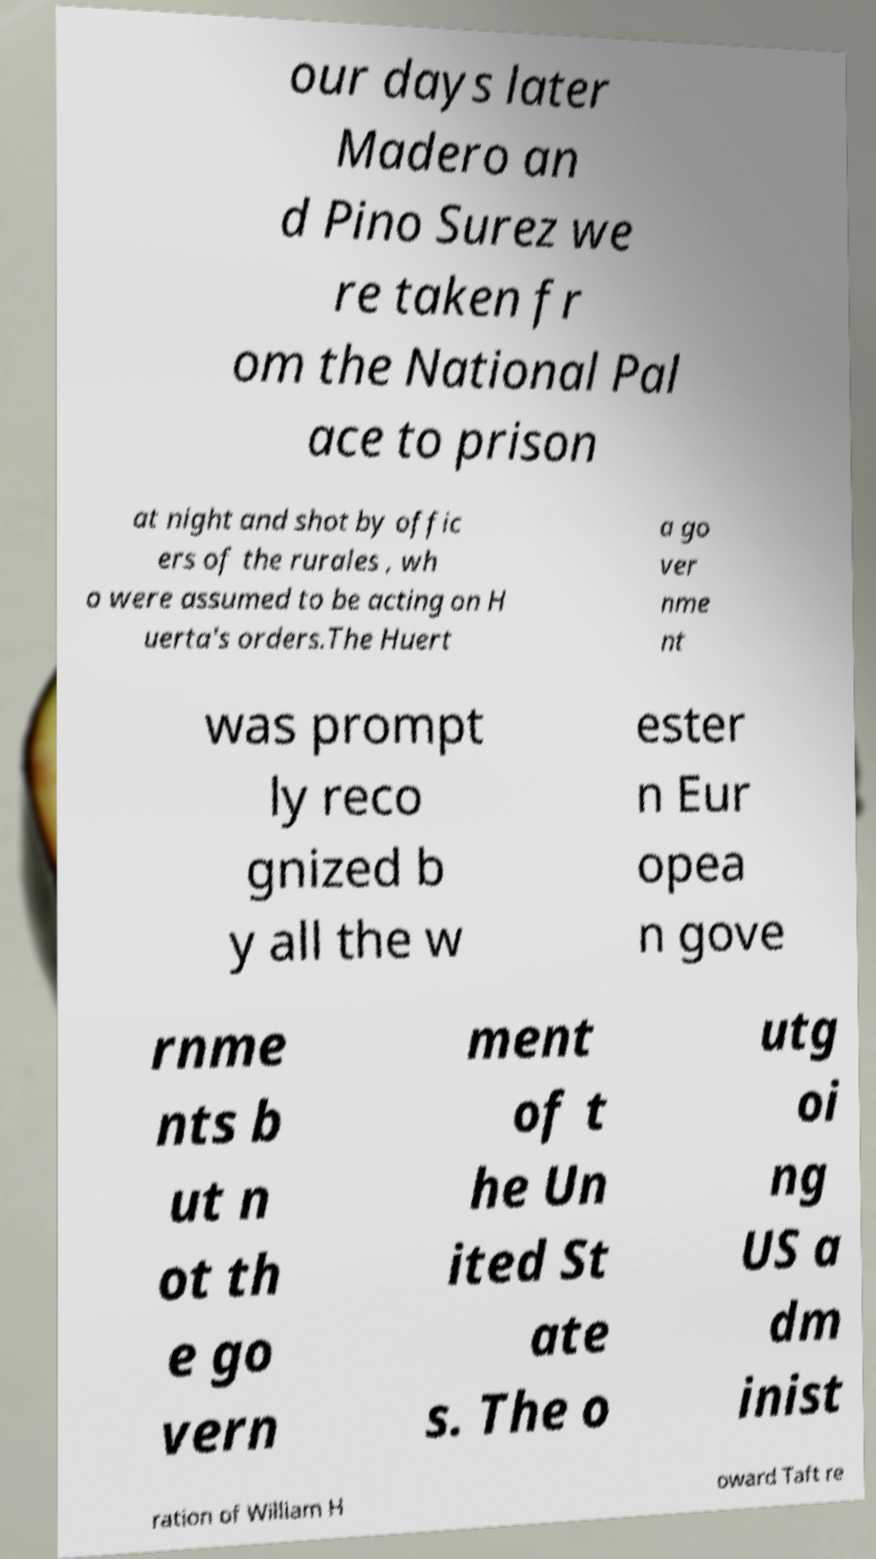Please identify and transcribe the text found in this image. our days later Madero an d Pino Surez we re taken fr om the National Pal ace to prison at night and shot by offic ers of the rurales , wh o were assumed to be acting on H uerta's orders.The Huert a go ver nme nt was prompt ly reco gnized b y all the w ester n Eur opea n gove rnme nts b ut n ot th e go vern ment of t he Un ited St ate s. The o utg oi ng US a dm inist ration of William H oward Taft re 